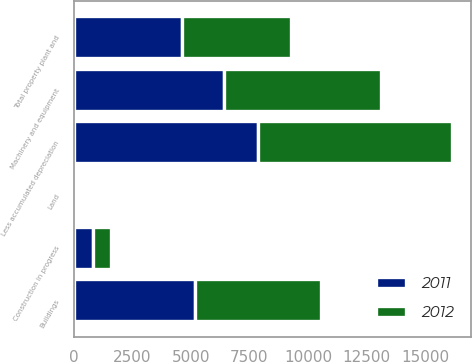Convert chart to OTSL. <chart><loc_0><loc_0><loc_500><loc_500><stacked_bar_chart><ecel><fcel>Land<fcel>Buildings<fcel>Machinery and equipment<fcel>Construction in progress<fcel>Less accumulated depreciation<fcel>Total property plant and<nl><fcel>2012<fcel>101<fcel>5388<fcel>6728<fcel>768<fcel>8310<fcel>4675<nl><fcel>2011<fcel>98<fcel>5159<fcel>6408<fcel>805<fcel>7859<fcel>4611<nl></chart> 